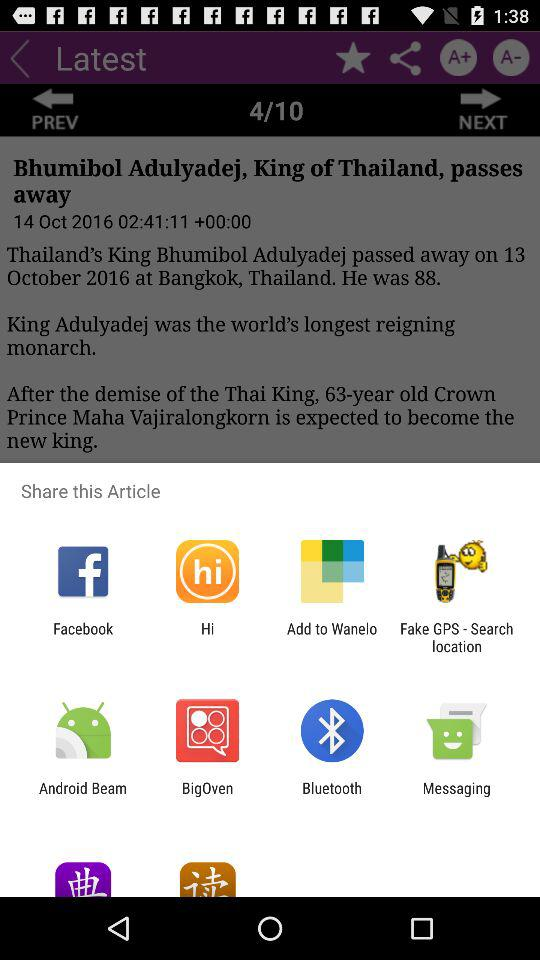What are the different applications through which we can share? Different applications through which we can share are: "Facebook", "Hi", "Add to Wanelo", "Fake GPS-Search location", "Android Beam", "BigOven", "Bluetooth", and "Messaging". 